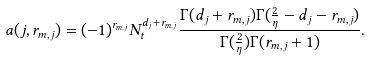<formula> <loc_0><loc_0><loc_500><loc_500>a ( j , r _ { m , j } ) = ( - 1 ) ^ { r _ { m , j } } N _ { t } ^ { d _ { j } + r _ { m , j } } \frac { \Gamma ( d _ { j } + r _ { m , j } ) \Gamma ( \frac { 2 } { \eta } - d _ { j } - r _ { m , j } ) } { \Gamma ( \frac { 2 } { \eta } ) \Gamma ( r _ { m , j } + 1 ) } .</formula> 